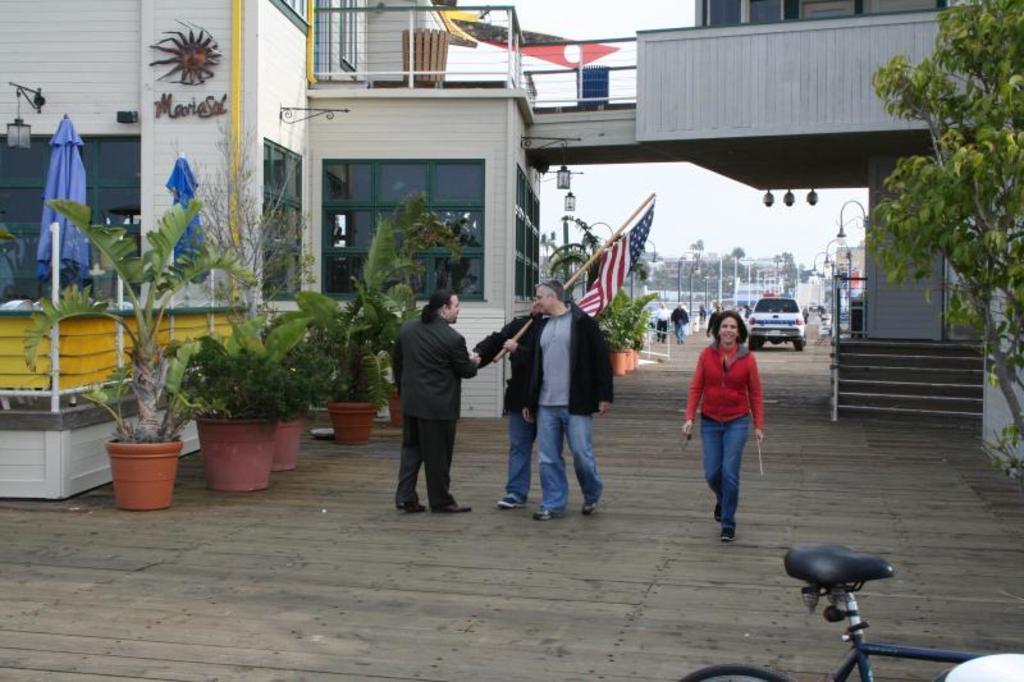Could you give a brief overview of what you see in this image? In this picture we can see buildings, potted plants and some people are standing and holding a flag. 